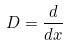<formula> <loc_0><loc_0><loc_500><loc_500>D = \frac { d } { d x }</formula> 